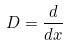<formula> <loc_0><loc_0><loc_500><loc_500>D = \frac { d } { d x }</formula> 